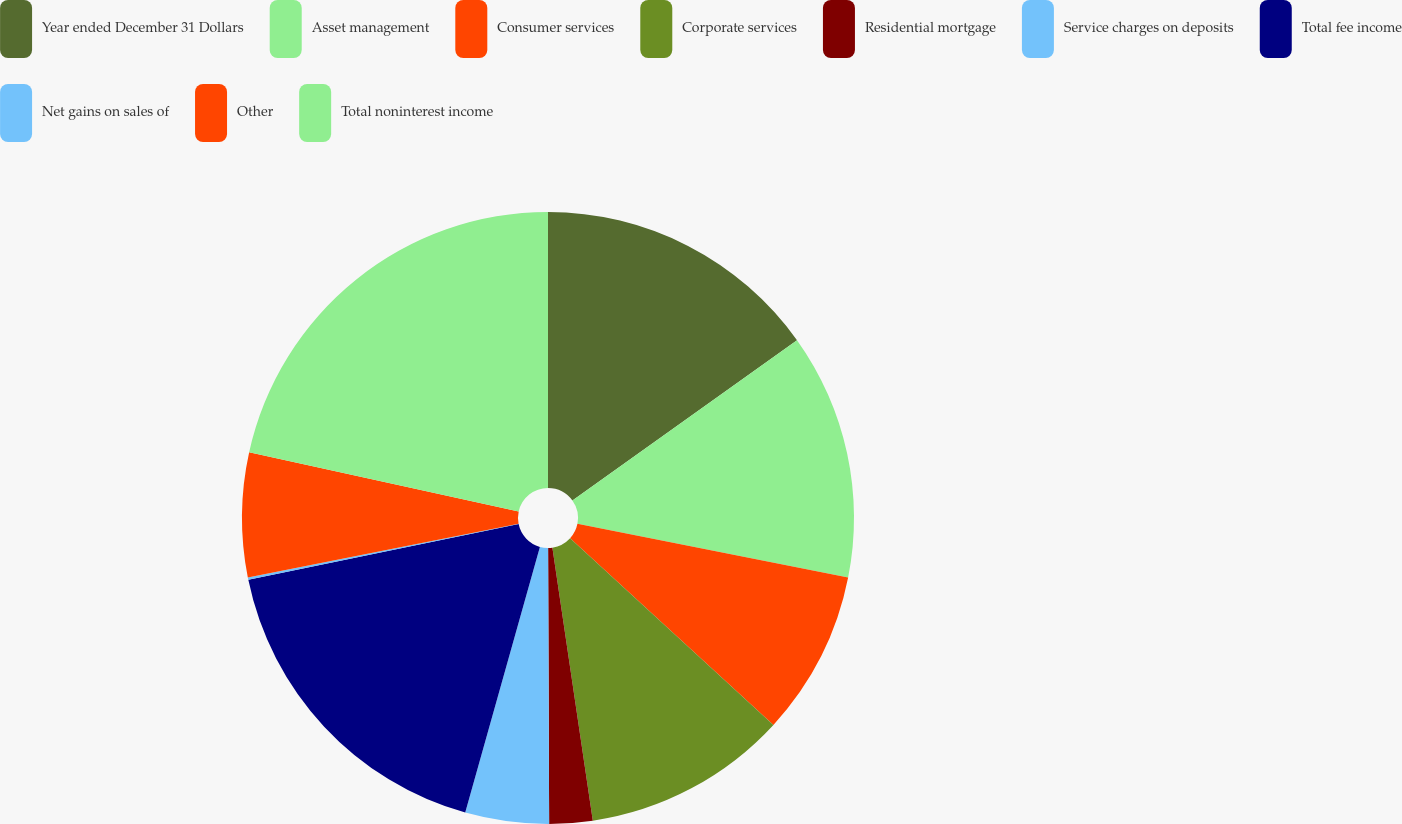Convert chart to OTSL. <chart><loc_0><loc_0><loc_500><loc_500><pie_chart><fcel>Year ended December 31 Dollars<fcel>Asset management<fcel>Consumer services<fcel>Corporate services<fcel>Residential mortgage<fcel>Service charges on deposits<fcel>Total fee income<fcel>Net gains on sales of<fcel>Other<fcel>Total noninterest income<nl><fcel>15.13%<fcel>12.99%<fcel>8.7%<fcel>10.84%<fcel>2.28%<fcel>4.42%<fcel>17.4%<fcel>0.13%<fcel>6.56%<fcel>21.55%<nl></chart> 